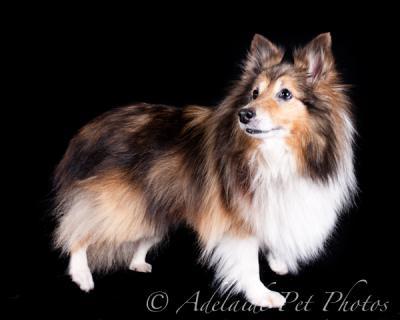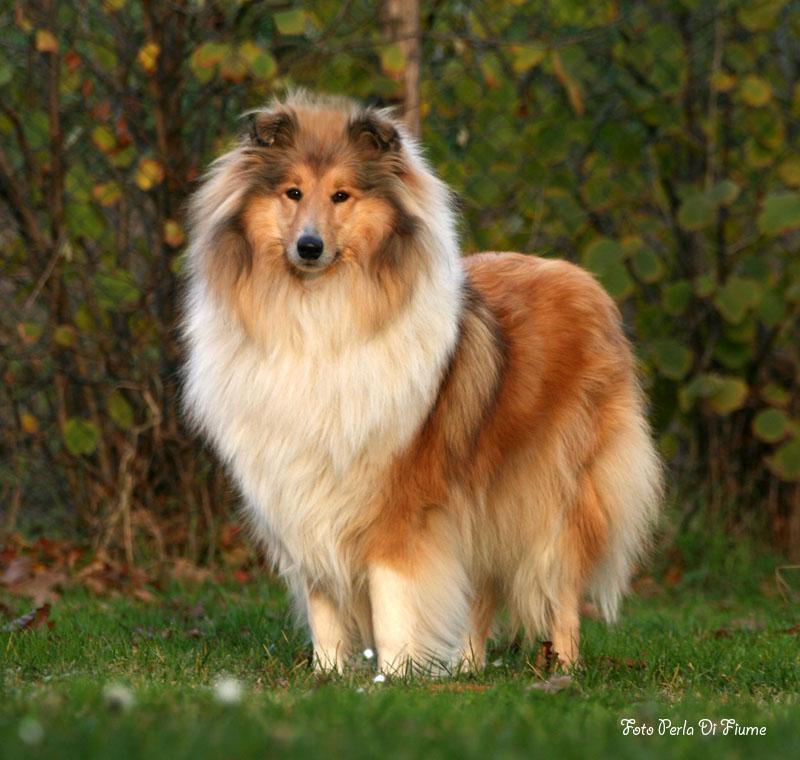The first image is the image on the left, the second image is the image on the right. Analyze the images presented: Is the assertion "the collie on the left image is sitting with its front legs straight up." valid? Answer yes or no. No. 